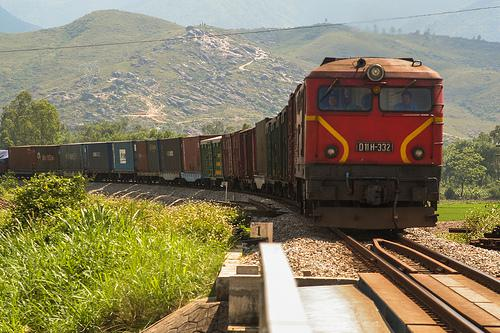Question: what is on the mountain?
Choices:
A. Trees.
B. Snow.
C. Birds.
D. Shrubbery.
Answer with the letter. Answer: A Question: what is in the background?
Choices:
A. Trees.
B. Apartment building.
C. Moon.
D. Mountain.
Answer with the letter. Answer: D Question: where are the mountains?
Choices:
A. In the distance.
B. To the left hand side.
C. Behind the field.
D. By the ocean.
Answer with the letter. Answer: C 